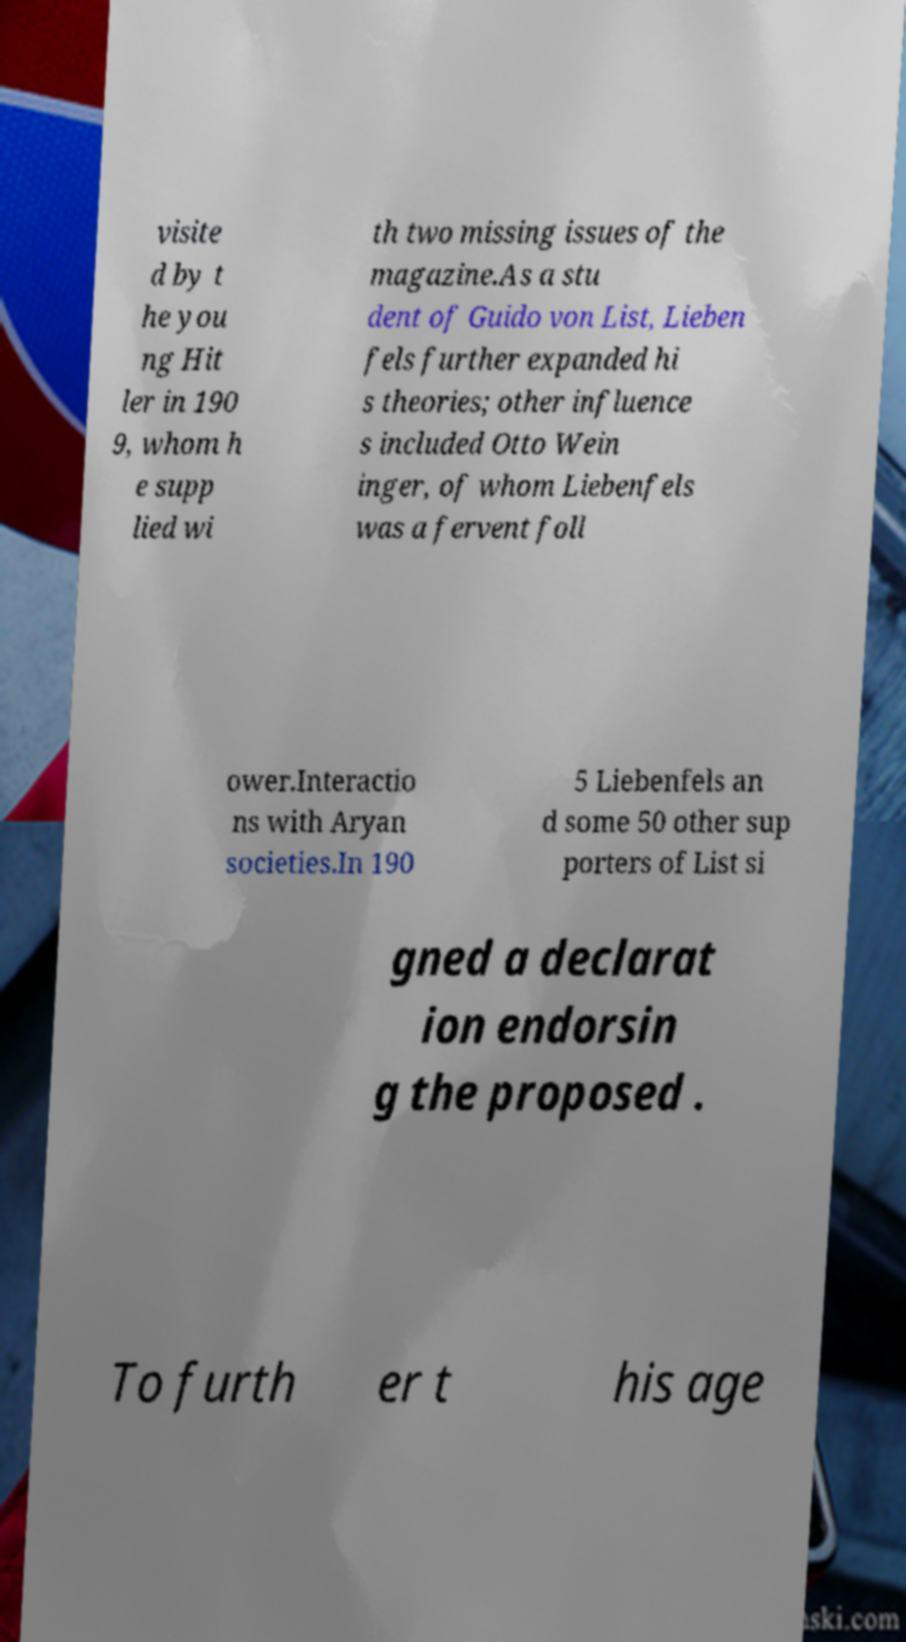I need the written content from this picture converted into text. Can you do that? visite d by t he you ng Hit ler in 190 9, whom h e supp lied wi th two missing issues of the magazine.As a stu dent of Guido von List, Lieben fels further expanded hi s theories; other influence s included Otto Wein inger, of whom Liebenfels was a fervent foll ower.Interactio ns with Aryan societies.In 190 5 Liebenfels an d some 50 other sup porters of List si gned a declarat ion endorsin g the proposed . To furth er t his age 